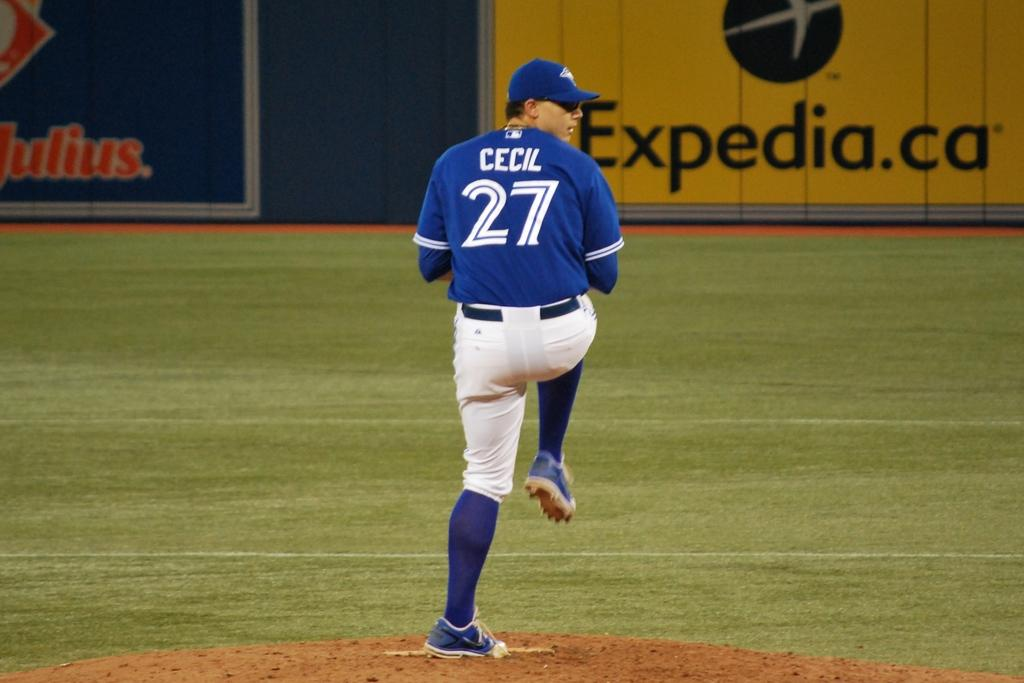<image>
Describe the image concisely. Cecil, who is player number 27 on the team, prepared to pitch the baseball. 